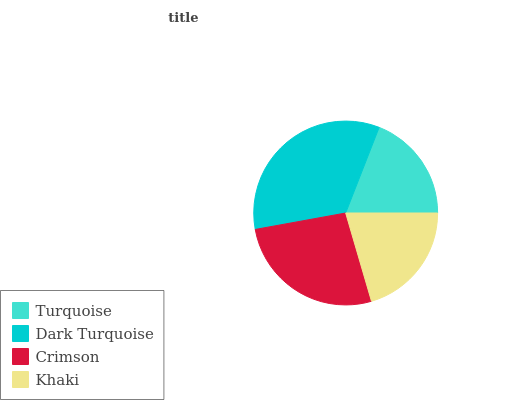Is Turquoise the minimum?
Answer yes or no. Yes. Is Dark Turquoise the maximum?
Answer yes or no. Yes. Is Crimson the minimum?
Answer yes or no. No. Is Crimson the maximum?
Answer yes or no. No. Is Dark Turquoise greater than Crimson?
Answer yes or no. Yes. Is Crimson less than Dark Turquoise?
Answer yes or no. Yes. Is Crimson greater than Dark Turquoise?
Answer yes or no. No. Is Dark Turquoise less than Crimson?
Answer yes or no. No. Is Crimson the high median?
Answer yes or no. Yes. Is Khaki the low median?
Answer yes or no. Yes. Is Dark Turquoise the high median?
Answer yes or no. No. Is Turquoise the low median?
Answer yes or no. No. 